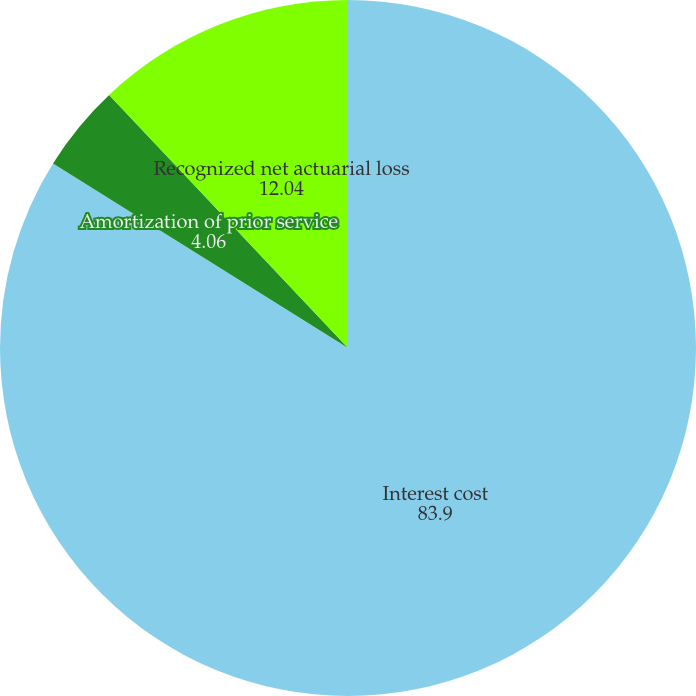Convert chart to OTSL. <chart><loc_0><loc_0><loc_500><loc_500><pie_chart><fcel>Interest cost<fcel>Amortization of prior service<fcel>Recognized net actuarial loss<nl><fcel>83.9%<fcel>4.06%<fcel>12.04%<nl></chart> 